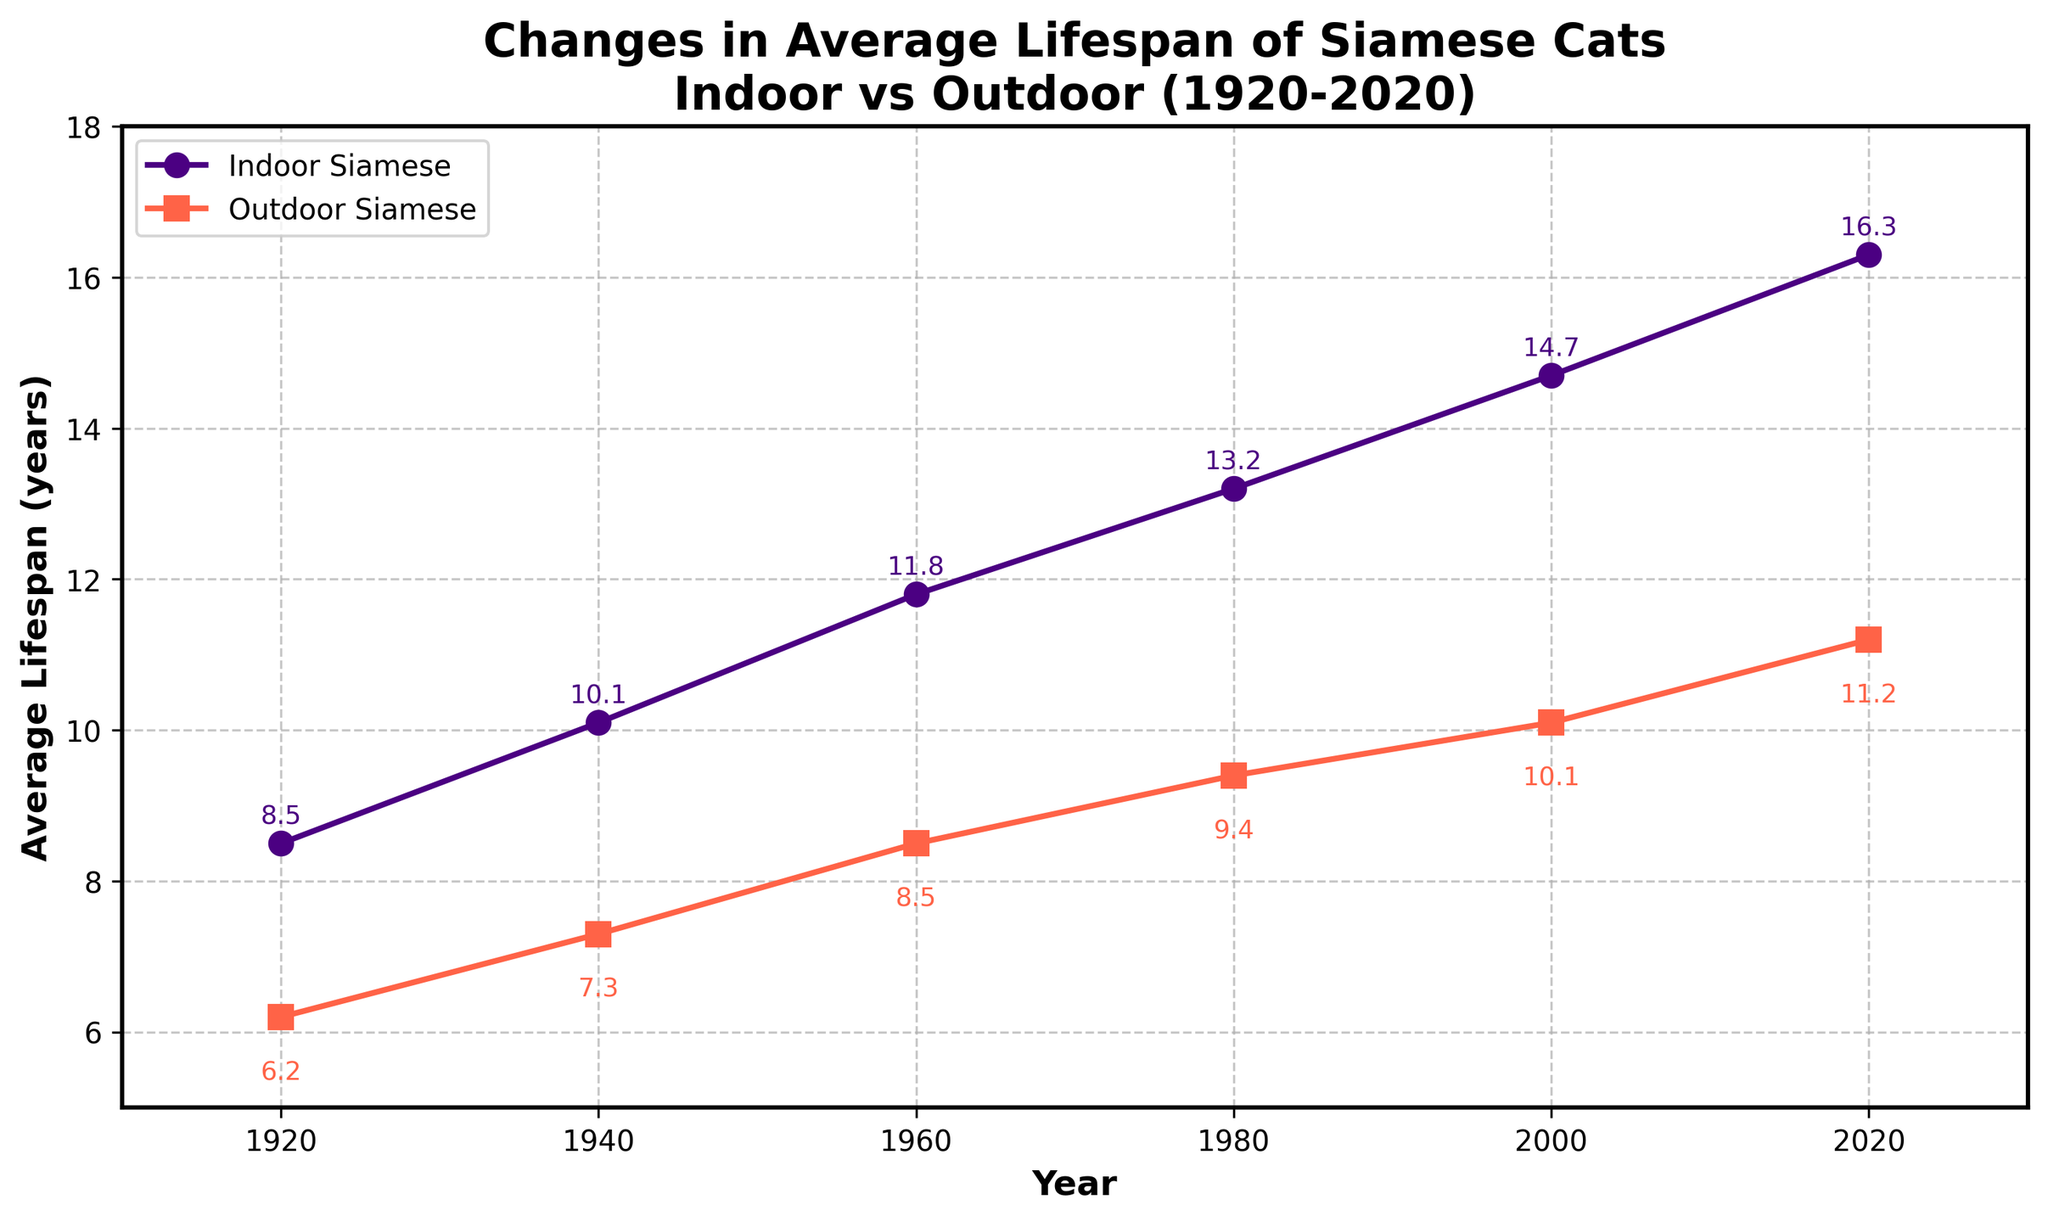What's the increase in average lifespan for indoor Siamese cats from 1920 to 2020? First, find the average lifespan of indoor Siamese cats in 1920 (8.5 years) and in 2020 (16.3 years). Then subtract the 1920 value from the 2020 value: 16.3 - 8.5 = 7.8 years.
Answer: 7.8 years What's the difference in lifespan between indoor and outdoor Siamese cats in the year 2000? In 2000, the average lifespan for indoor Siamese cats is 14.7 years, and for outdoor Siamese cats, it is 10.1 years. Subtract the lifespan of outdoor Siamese cats from that of indoor Siamese cats: 14.7 - 10.1 = 4.6 years.
Answer: 4.6 years By how many years did the average lifespan of outdoor Siamese cats increase from 1920 to 1940? In 1920, the average lifespan for outdoor Siamese cats is 6.2 years, and in 1940, it is 7.3 years. Subtract the 1920 value from the 1940 value: 7.3 - 6.2 = 1.1 years.
Answer: 1.1 years In which year was the gap between indoor and outdoor Siamese cat lifespans the smallest? To determine the year with the smallest gap, calculate the difference between indoor and outdoor lifespans for each year: 1920: 8.5-6.2=2.3, 1940: 10.1-7.3=2.8, 1960: 11.8-8.5=3.3, 1980: 13.2-9.4=3.8, 2000: 14.7-10.1=4.6, 2020: 16.3-11.2=5.1. The smallest gap is in 1920 (2.3 years).
Answer: 1920 Which category of Siamese cats has shown a greater improvement in life expectancy from 1920 to 2020? Calculate the increase in lifespan for both categories from 1920 to 2020: Indoor: 16.3 - 8.5 = 7.8 years; Outdoor: 11.2 - 6.2 = 5.0 years. The indoor category has shown a greater improvement.
Answer: Indoor Siamese cats In 1960, how much longer did indoor Siamese cats live compared to outdoor ones? In 1960, the average lifespan for indoor Siamese cats is 11.8 years, and for outdoor Siamese cats, it is 8.5 years. Subtract the outdoor value from the indoor value: 11.8 - 8.5 = 3.3 years.
Answer: 3.3 years What's the average lifespan of indoor Siamese cats over the period 1920 to 2020? Add the lifespans of indoor Siamese cats for all years: 8.5, 10.1, 11.8, 13.2, 14.7, 16.3. The sum is 74.6. There are 6 data points, so the average is 74.6 / 6 = 12.43 years.
Answer: 12.43 years How do the indoor and outdoor categories' trends compare in terms of lifespan improvement? Both categories show an upward trend in lifespan over the years. Indoor cats increased from 8.5 (1920) to 16.3 (2020), while outdoor cats increased from 6.2 (1920) to 11.2 (2020). Indoor cats show a steeper increase.
Answer: Indoor cats show a steeper increase 